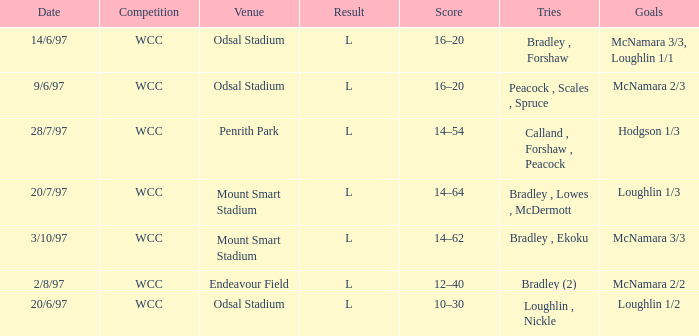What was the score on 20/6/97? 10–30. 